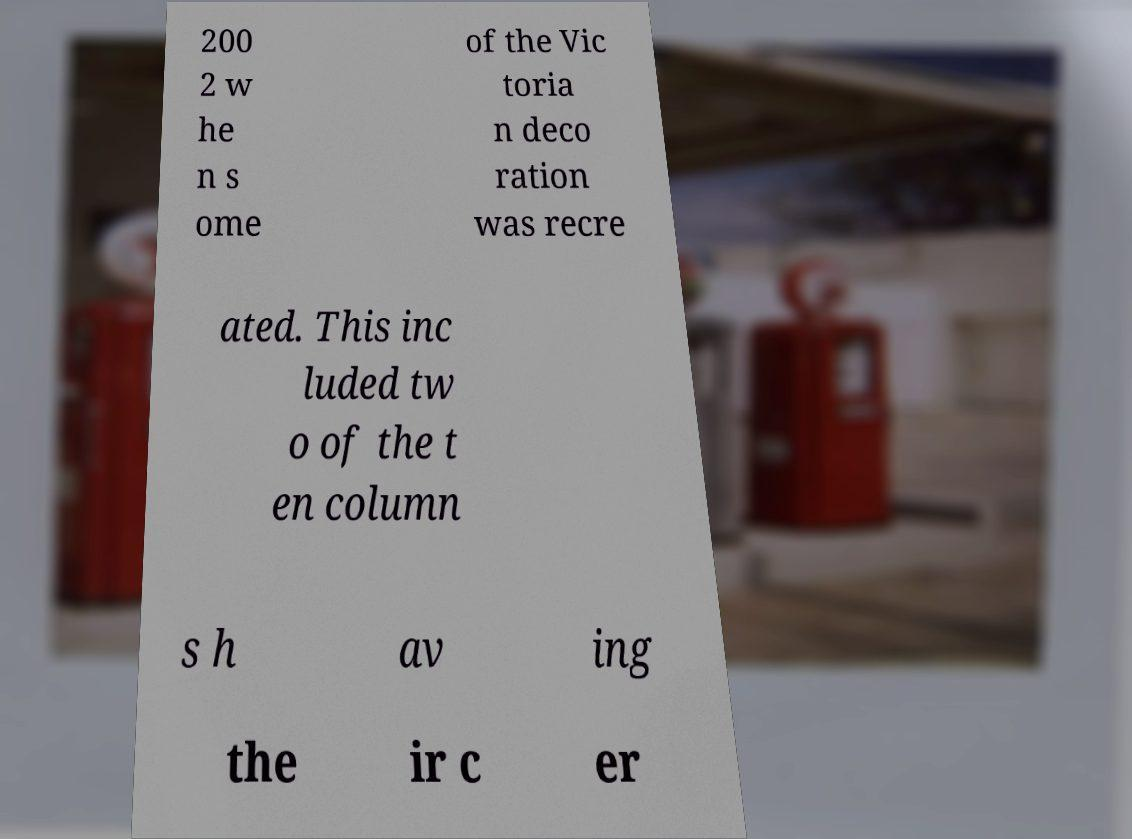For documentation purposes, I need the text within this image transcribed. Could you provide that? 200 2 w he n s ome of the Vic toria n deco ration was recre ated. This inc luded tw o of the t en column s h av ing the ir c er 